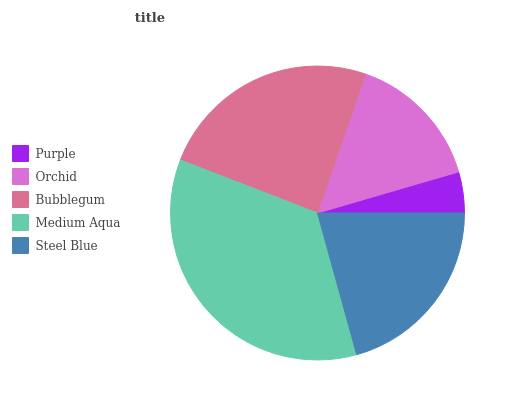Is Purple the minimum?
Answer yes or no. Yes. Is Medium Aqua the maximum?
Answer yes or no. Yes. Is Orchid the minimum?
Answer yes or no. No. Is Orchid the maximum?
Answer yes or no. No. Is Orchid greater than Purple?
Answer yes or no. Yes. Is Purple less than Orchid?
Answer yes or no. Yes. Is Purple greater than Orchid?
Answer yes or no. No. Is Orchid less than Purple?
Answer yes or no. No. Is Steel Blue the high median?
Answer yes or no. Yes. Is Steel Blue the low median?
Answer yes or no. Yes. Is Bubblegum the high median?
Answer yes or no. No. Is Medium Aqua the low median?
Answer yes or no. No. 